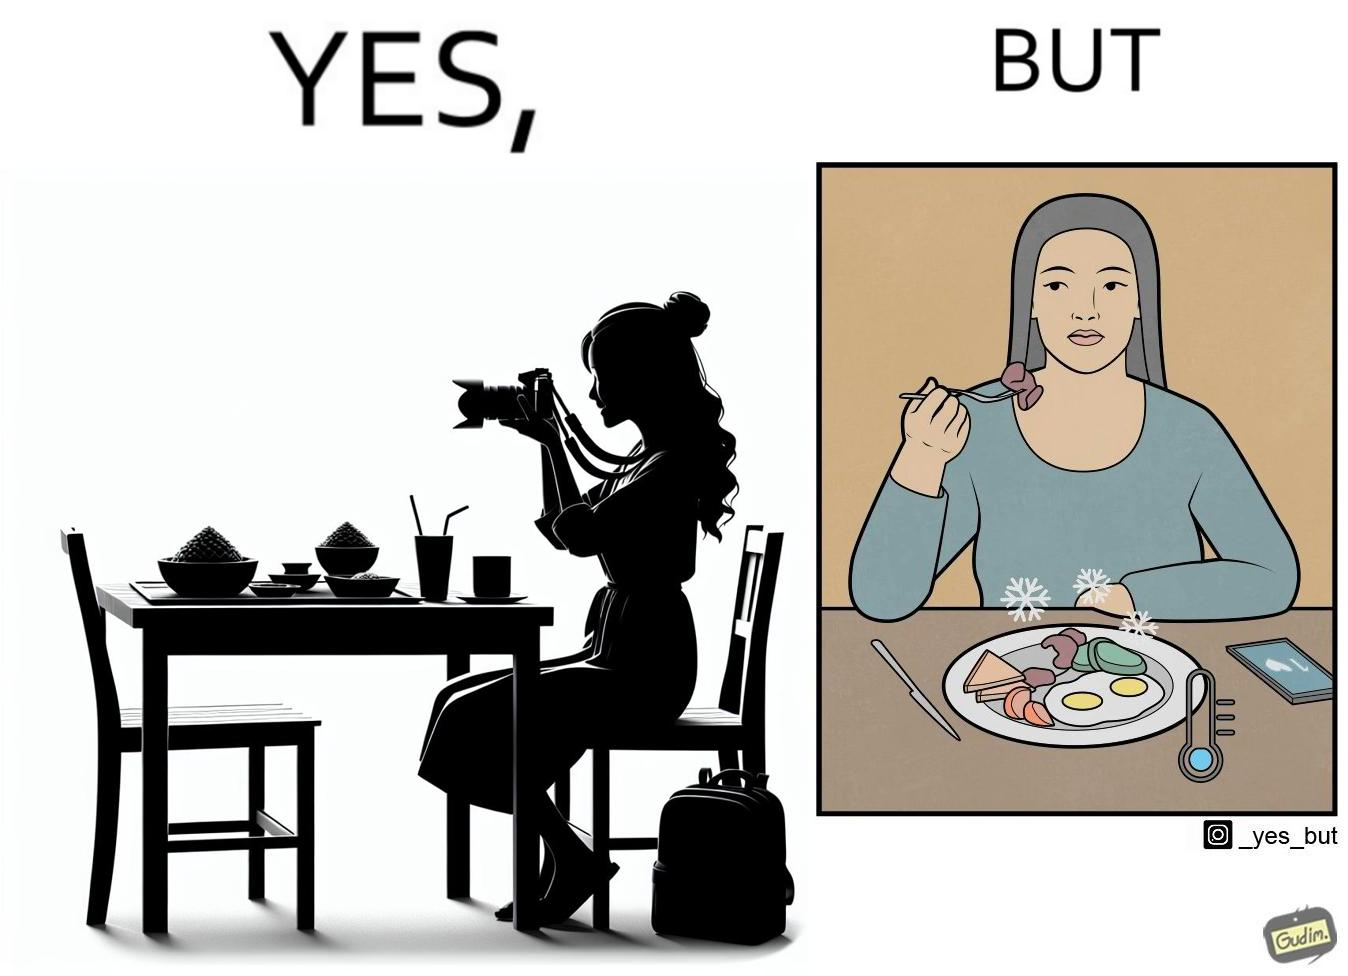Compare the left and right sides of this image. In the left part of the image: It is a woman taking pictures of her food In the right part of the image: It is a woman eating cold food 